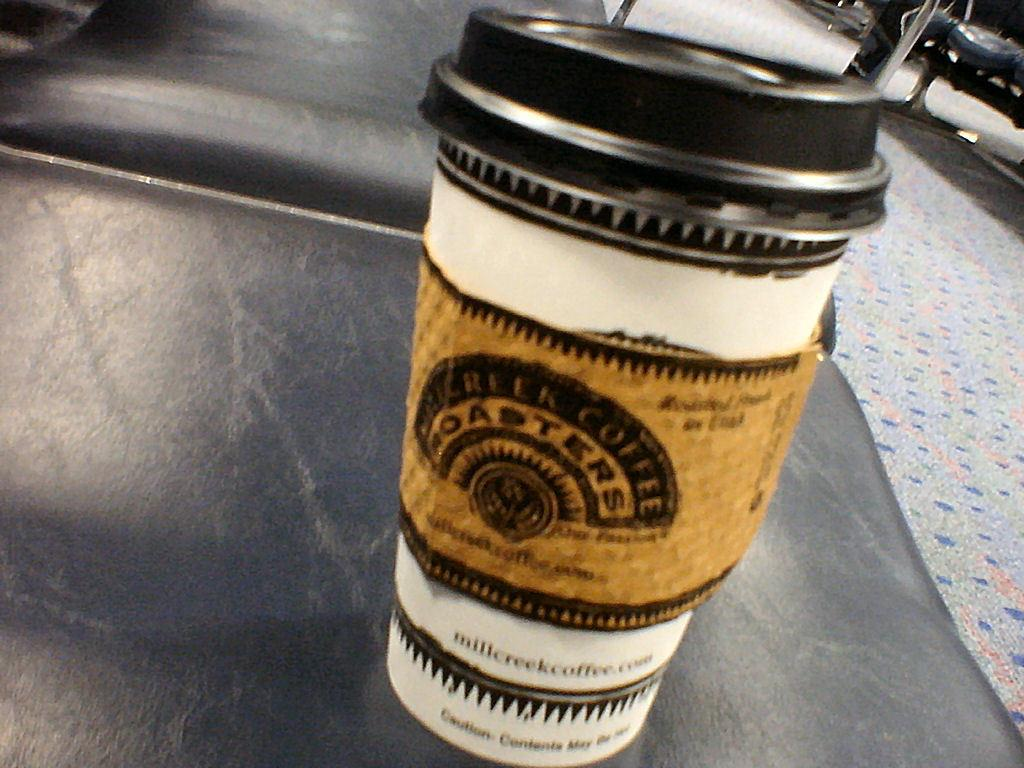<image>
Provide a brief description of the given image. A one-use coffee cup with lid from Millcreek Coffee Roasters sitting on a leather chair. 